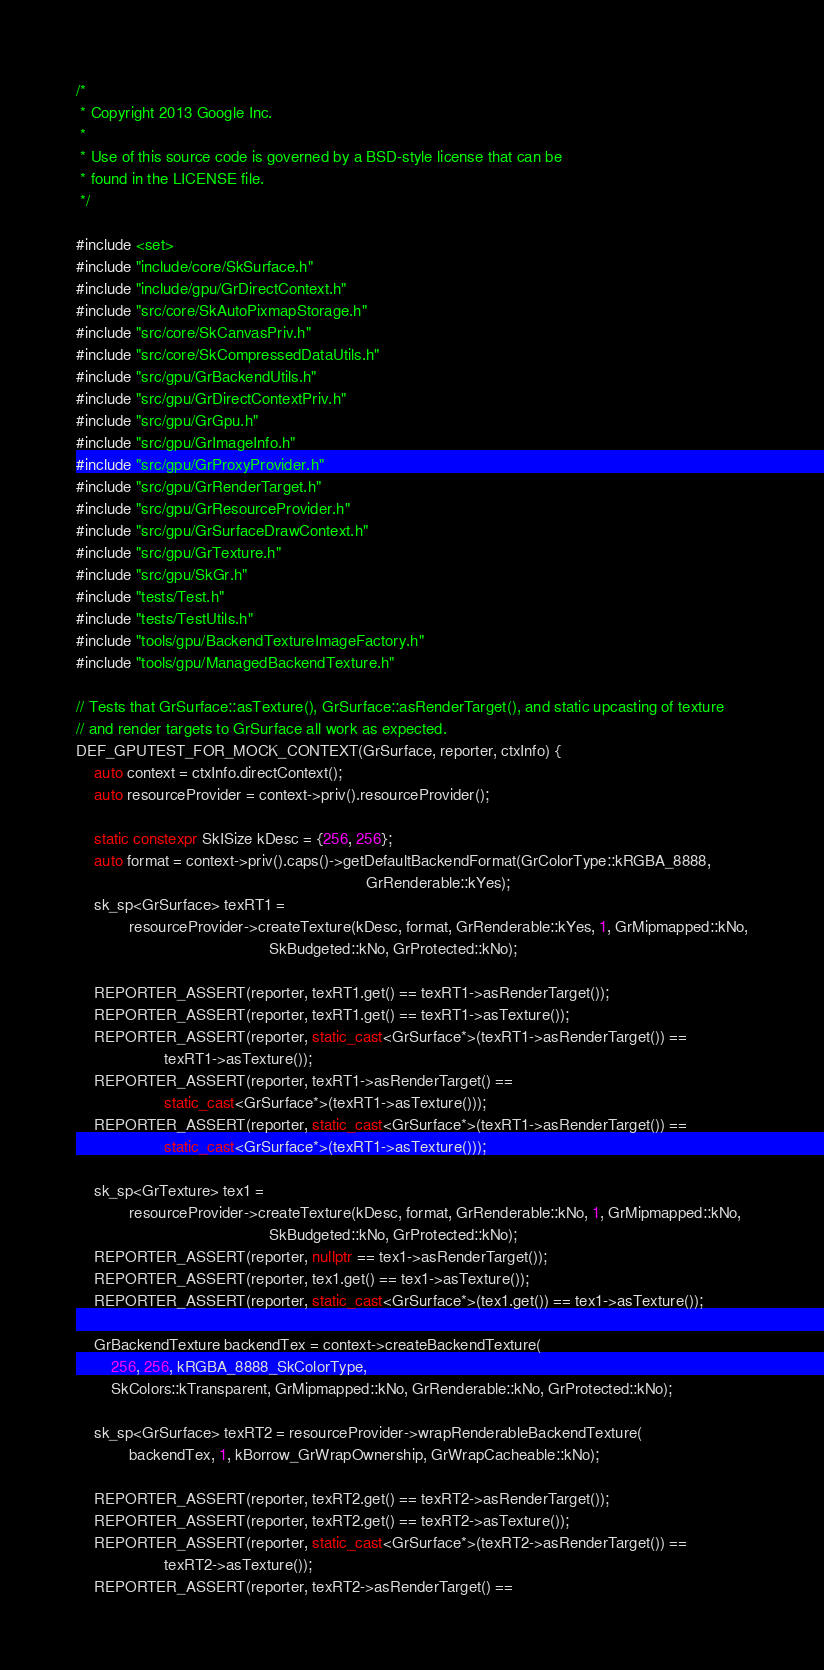<code> <loc_0><loc_0><loc_500><loc_500><_C++_>/*
 * Copyright 2013 Google Inc.
 *
 * Use of this source code is governed by a BSD-style license that can be
 * found in the LICENSE file.
 */

#include <set>
#include "include/core/SkSurface.h"
#include "include/gpu/GrDirectContext.h"
#include "src/core/SkAutoPixmapStorage.h"
#include "src/core/SkCanvasPriv.h"
#include "src/core/SkCompressedDataUtils.h"
#include "src/gpu/GrBackendUtils.h"
#include "src/gpu/GrDirectContextPriv.h"
#include "src/gpu/GrGpu.h"
#include "src/gpu/GrImageInfo.h"
#include "src/gpu/GrProxyProvider.h"
#include "src/gpu/GrRenderTarget.h"
#include "src/gpu/GrResourceProvider.h"
#include "src/gpu/GrSurfaceDrawContext.h"
#include "src/gpu/GrTexture.h"
#include "src/gpu/SkGr.h"
#include "tests/Test.h"
#include "tests/TestUtils.h"
#include "tools/gpu/BackendTextureImageFactory.h"
#include "tools/gpu/ManagedBackendTexture.h"

// Tests that GrSurface::asTexture(), GrSurface::asRenderTarget(), and static upcasting of texture
// and render targets to GrSurface all work as expected.
DEF_GPUTEST_FOR_MOCK_CONTEXT(GrSurface, reporter, ctxInfo) {
    auto context = ctxInfo.directContext();
    auto resourceProvider = context->priv().resourceProvider();

    static constexpr SkISize kDesc = {256, 256};
    auto format = context->priv().caps()->getDefaultBackendFormat(GrColorType::kRGBA_8888,
                                                                  GrRenderable::kYes);
    sk_sp<GrSurface> texRT1 =
            resourceProvider->createTexture(kDesc, format, GrRenderable::kYes, 1, GrMipmapped::kNo,
                                            SkBudgeted::kNo, GrProtected::kNo);

    REPORTER_ASSERT(reporter, texRT1.get() == texRT1->asRenderTarget());
    REPORTER_ASSERT(reporter, texRT1.get() == texRT1->asTexture());
    REPORTER_ASSERT(reporter, static_cast<GrSurface*>(texRT1->asRenderTarget()) ==
                    texRT1->asTexture());
    REPORTER_ASSERT(reporter, texRT1->asRenderTarget() ==
                    static_cast<GrSurface*>(texRT1->asTexture()));
    REPORTER_ASSERT(reporter, static_cast<GrSurface*>(texRT1->asRenderTarget()) ==
                    static_cast<GrSurface*>(texRT1->asTexture()));

    sk_sp<GrTexture> tex1 =
            resourceProvider->createTexture(kDesc, format, GrRenderable::kNo, 1, GrMipmapped::kNo,
                                            SkBudgeted::kNo, GrProtected::kNo);
    REPORTER_ASSERT(reporter, nullptr == tex1->asRenderTarget());
    REPORTER_ASSERT(reporter, tex1.get() == tex1->asTexture());
    REPORTER_ASSERT(reporter, static_cast<GrSurface*>(tex1.get()) == tex1->asTexture());

    GrBackendTexture backendTex = context->createBackendTexture(
        256, 256, kRGBA_8888_SkColorType,
        SkColors::kTransparent, GrMipmapped::kNo, GrRenderable::kNo, GrProtected::kNo);

    sk_sp<GrSurface> texRT2 = resourceProvider->wrapRenderableBackendTexture(
            backendTex, 1, kBorrow_GrWrapOwnership, GrWrapCacheable::kNo);

    REPORTER_ASSERT(reporter, texRT2.get() == texRT2->asRenderTarget());
    REPORTER_ASSERT(reporter, texRT2.get() == texRT2->asTexture());
    REPORTER_ASSERT(reporter, static_cast<GrSurface*>(texRT2->asRenderTarget()) ==
                    texRT2->asTexture());
    REPORTER_ASSERT(reporter, texRT2->asRenderTarget() ==</code> 